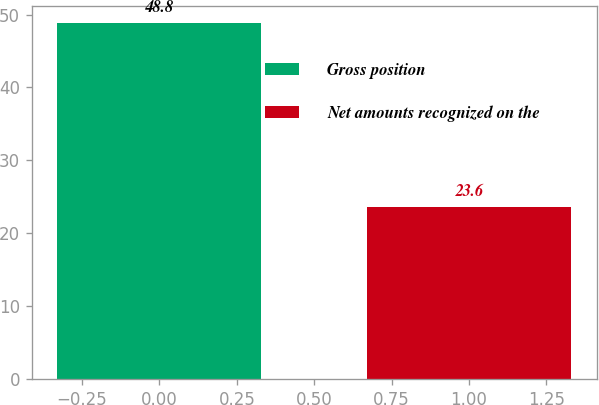Convert chart to OTSL. <chart><loc_0><loc_0><loc_500><loc_500><bar_chart><fcel>Gross position<fcel>Net amounts recognized on the<nl><fcel>48.8<fcel>23.6<nl></chart> 